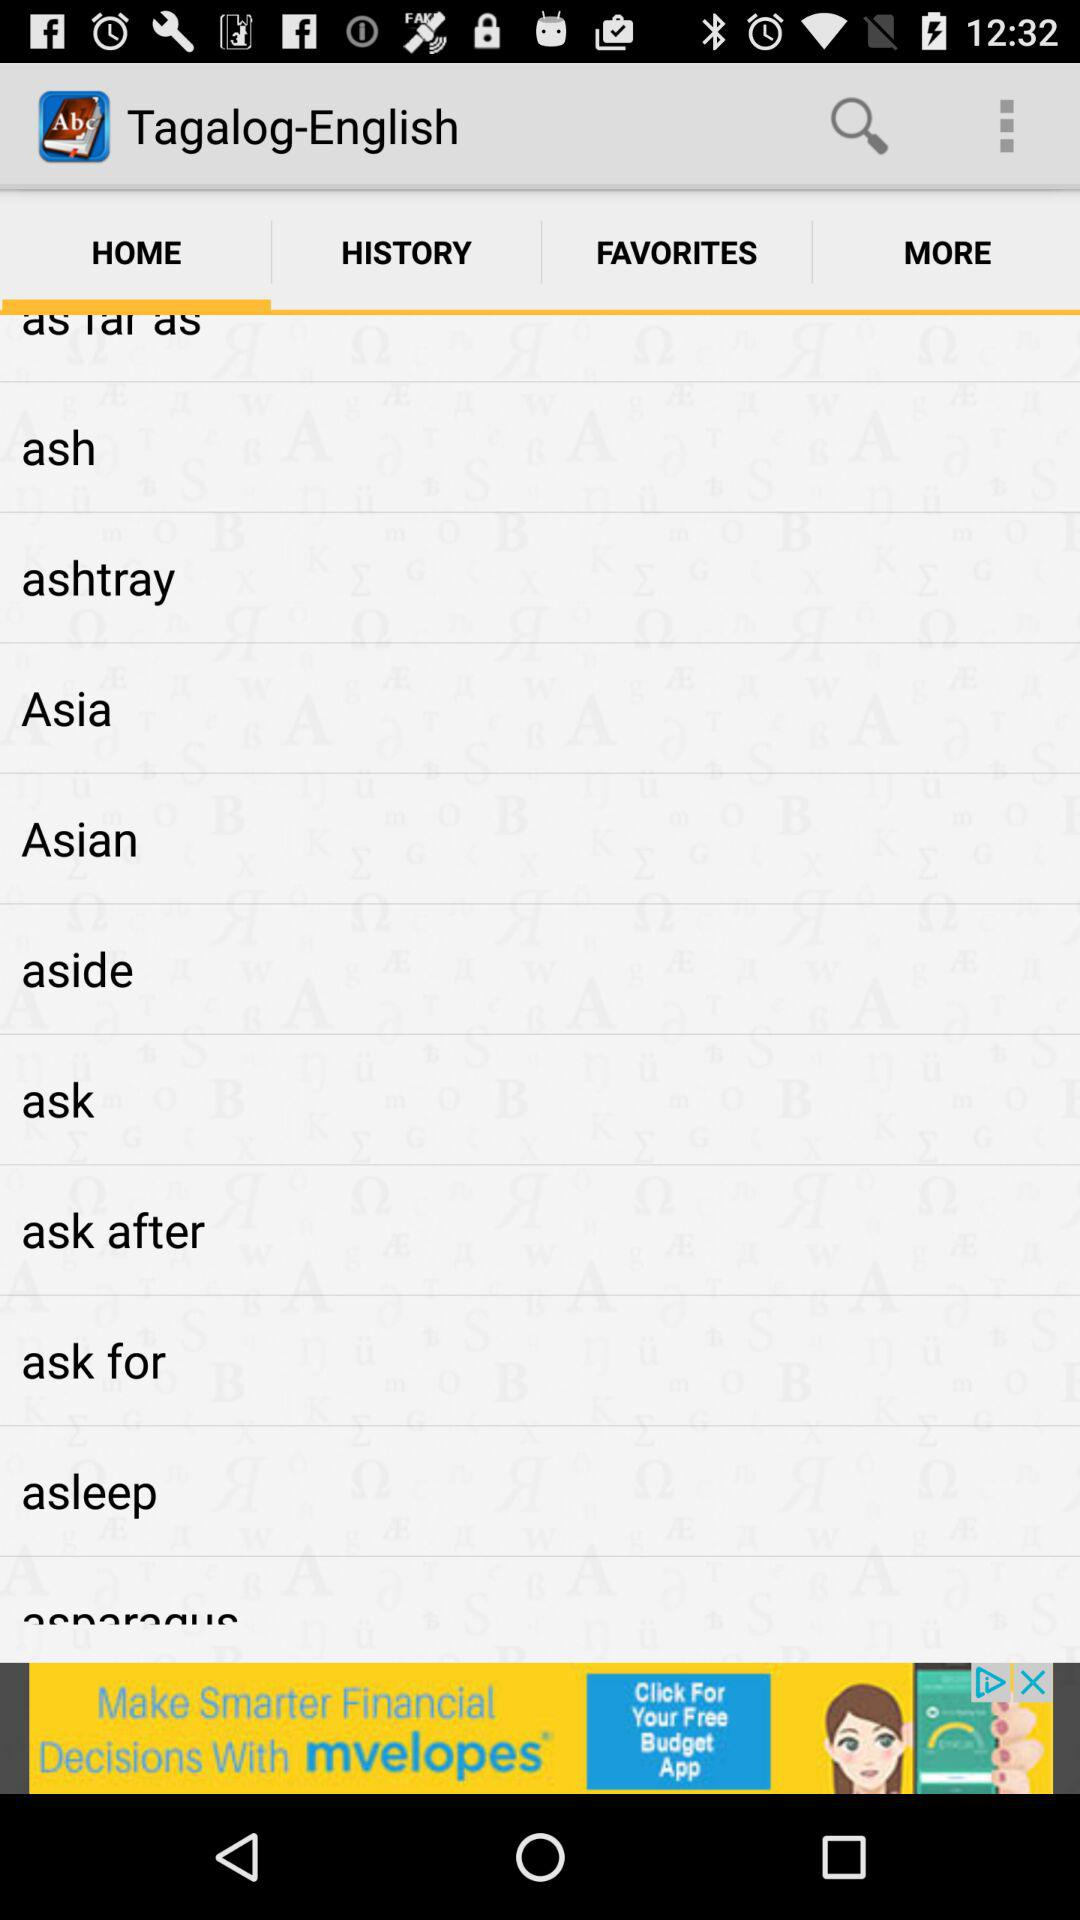What is the selected tab? The selected tab is "HOME". 